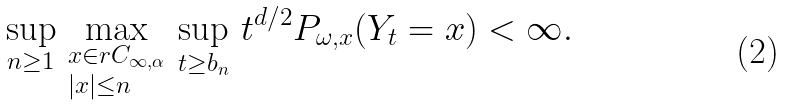Convert formula to latex. <formula><loc_0><loc_0><loc_500><loc_500>\sup _ { n \geq 1 } \, \max _ { \begin{subarray} { c } x \in r C _ { \infty , \alpha } \\ | x | \leq n \end{subarray} } \, \sup _ { t \geq b _ { n } } \, t ^ { d / 2 } P _ { \omega , x } ( Y _ { t } = x ) < \infty .</formula> 